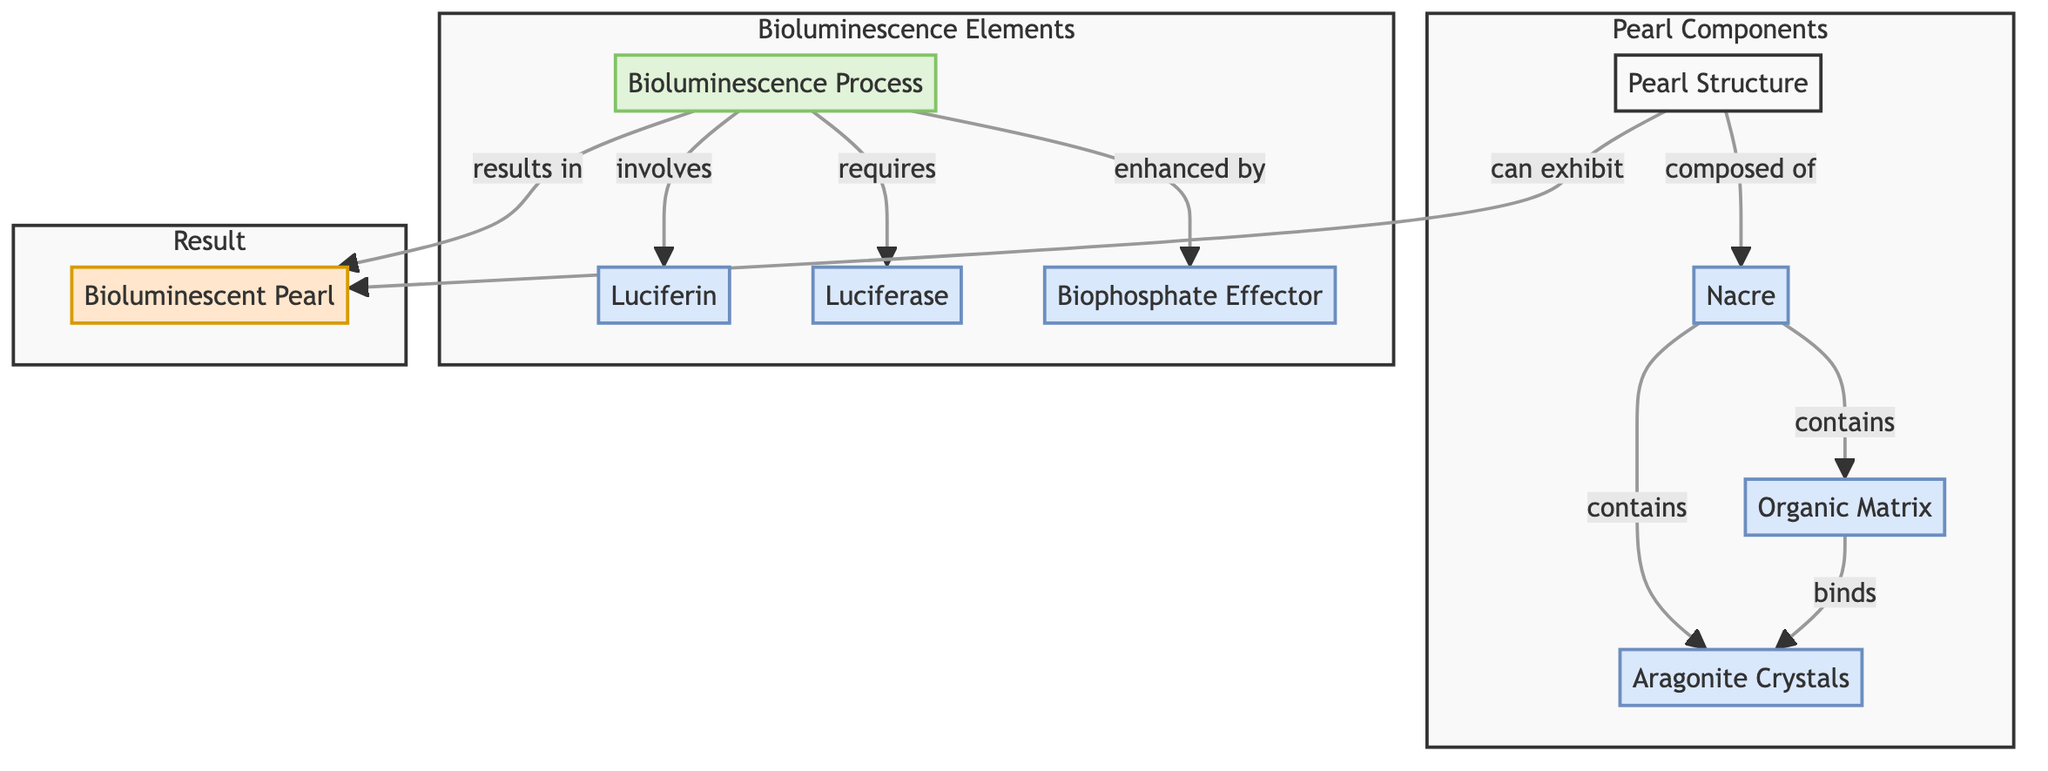What are the main components of a pearl structure? The diagram indicates that the pearl structure comprises nacre, aragonite crystals, and an organic matrix. These nodes are directly linked to the pearl structure node.
Answer: nacre, aragonite crystals, organic matrix What process is involved in bioluminescence? The diagram specifies that the bioluminescence process involves luciferin and requires luciferase. Both components are directly connected to the bioluminescence process node.
Answer: luciferin, luciferase How many components are present in the Pearl Components subgraph? By counting the nodes in the Pearl Components subgraph, we find four nodes: pearl structure, nacre, aragonite crystals, and organic matrix.
Answer: 4 What enhances the bioluminescence process? According to the diagram, the biophosphate effector is indicated as enhancing the bioluminescence process. This relationship is explicitly stated between the biophosphate effector and bioluminescence process nodes.
Answer: biophosphate effector What is the output of the bioluminescence process? The diagram shows that the result of the bioluminescence process is a bioluminescent pearl. This is a direct outcome as represented by the connection leading to the pearl_bioluminescence node.
Answer: bioluminescent pearl Which component binds the aragonite crystals? The organic matrix is identified in the diagram as the component that binds the aragonite crystals. This is depicted with a direct connection between the organic matrix and aragonite crystals nodes.
Answer: organic matrix What type of crystals are in the nacre? The diagram specifies that aragonite crystals are contained within nacre. Thus, the type of crystals is directly mentioned as part of the components of nacre.
Answer: aragonite crystals How many nodes are representing bioluminescence elements? The diagram indicates that there are four nodes representing bioluminescence elements which are the bioluminescence process, luciferin, luciferase, and biophosphate effector.
Answer: 4 What does the pearl structure can exhibit? The diagram clearly states that the pearl structure can exhibit pearl bioluminescence, indicated by the directed edge from pearl structure to pearl_bioluminescence.
Answer: pearl bioluminescence 